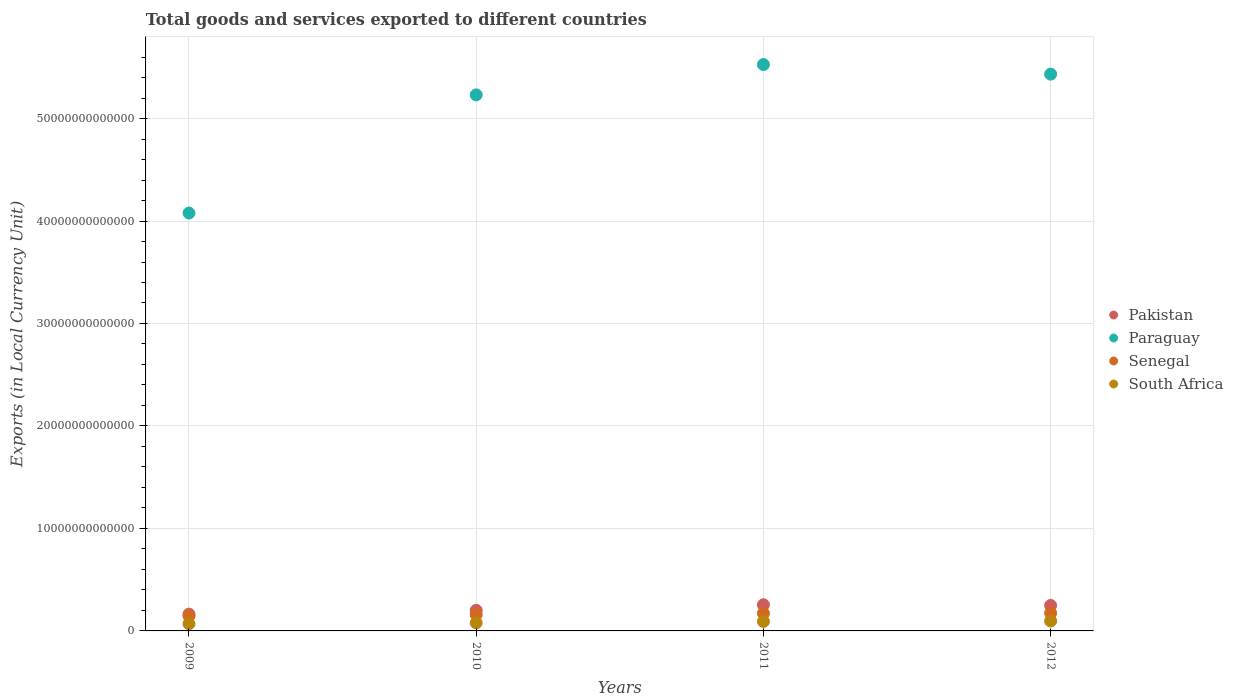Is the number of dotlines equal to the number of legend labels?
Make the answer very short. Yes. What is the Amount of goods and services exports in South Africa in 2011?
Make the answer very short. 9.21e+11. Across all years, what is the maximum Amount of goods and services exports in Senegal?
Ensure brevity in your answer.  1.74e+12. Across all years, what is the minimum Amount of goods and services exports in Senegal?
Make the answer very short. 1.47e+12. In which year was the Amount of goods and services exports in Senegal maximum?
Your answer should be very brief. 2012. What is the total Amount of goods and services exports in Senegal in the graph?
Provide a succinct answer. 6.52e+12. What is the difference between the Amount of goods and services exports in Paraguay in 2009 and that in 2012?
Your response must be concise. -1.36e+13. What is the difference between the Amount of goods and services exports in Pakistan in 2011 and the Amount of goods and services exports in Paraguay in 2010?
Make the answer very short. -4.98e+13. What is the average Amount of goods and services exports in Senegal per year?
Your answer should be compact. 1.63e+12. In the year 2011, what is the difference between the Amount of goods and services exports in Senegal and Amount of goods and services exports in Pakistan?
Keep it short and to the point. -8.38e+11. In how many years, is the Amount of goods and services exports in South Africa greater than 16000000000000 LCU?
Ensure brevity in your answer.  0. What is the ratio of the Amount of goods and services exports in Senegal in 2011 to that in 2012?
Provide a short and direct response. 0.98. What is the difference between the highest and the second highest Amount of goods and services exports in Senegal?
Ensure brevity in your answer.  2.69e+1. What is the difference between the highest and the lowest Amount of goods and services exports in South Africa?
Offer a terse response. 2.70e+11. Is the sum of the Amount of goods and services exports in Paraguay in 2011 and 2012 greater than the maximum Amount of goods and services exports in Senegal across all years?
Your response must be concise. Yes. Does the Amount of goods and services exports in Paraguay monotonically increase over the years?
Your response must be concise. No. Is the Amount of goods and services exports in Paraguay strictly less than the Amount of goods and services exports in Senegal over the years?
Offer a terse response. No. How many dotlines are there?
Your answer should be very brief. 4. What is the difference between two consecutive major ticks on the Y-axis?
Ensure brevity in your answer.  1.00e+13. Does the graph contain any zero values?
Provide a short and direct response. No. Where does the legend appear in the graph?
Your answer should be compact. Center right. How many legend labels are there?
Make the answer very short. 4. What is the title of the graph?
Your response must be concise. Total goods and services exported to different countries. What is the label or title of the X-axis?
Make the answer very short. Years. What is the label or title of the Y-axis?
Give a very brief answer. Exports (in Local Currency Unit). What is the Exports (in Local Currency Unit) in Pakistan in 2009?
Provide a short and direct response. 1.64e+12. What is the Exports (in Local Currency Unit) in Paraguay in 2009?
Provide a succinct answer. 4.08e+13. What is the Exports (in Local Currency Unit) of Senegal in 2009?
Offer a very short reply. 1.47e+12. What is the Exports (in Local Currency Unit) of South Africa in 2009?
Offer a terse response. 7.00e+11. What is the Exports (in Local Currency Unit) of Pakistan in 2010?
Provide a short and direct response. 2.01e+12. What is the Exports (in Local Currency Unit) of Paraguay in 2010?
Your answer should be compact. 5.23e+13. What is the Exports (in Local Currency Unit) in Senegal in 2010?
Keep it short and to the point. 1.59e+12. What is the Exports (in Local Currency Unit) in South Africa in 2010?
Keep it short and to the point. 7.86e+11. What is the Exports (in Local Currency Unit) of Pakistan in 2011?
Your response must be concise. 2.55e+12. What is the Exports (in Local Currency Unit) of Paraguay in 2011?
Your answer should be very brief. 5.53e+13. What is the Exports (in Local Currency Unit) of Senegal in 2011?
Keep it short and to the point. 1.71e+12. What is the Exports (in Local Currency Unit) of South Africa in 2011?
Provide a short and direct response. 9.21e+11. What is the Exports (in Local Currency Unit) of Pakistan in 2012?
Give a very brief answer. 2.49e+12. What is the Exports (in Local Currency Unit) of Paraguay in 2012?
Give a very brief answer. 5.43e+13. What is the Exports (in Local Currency Unit) in Senegal in 2012?
Your response must be concise. 1.74e+12. What is the Exports (in Local Currency Unit) of South Africa in 2012?
Offer a terse response. 9.70e+11. Across all years, what is the maximum Exports (in Local Currency Unit) in Pakistan?
Provide a short and direct response. 2.55e+12. Across all years, what is the maximum Exports (in Local Currency Unit) of Paraguay?
Keep it short and to the point. 5.53e+13. Across all years, what is the maximum Exports (in Local Currency Unit) in Senegal?
Your answer should be very brief. 1.74e+12. Across all years, what is the maximum Exports (in Local Currency Unit) of South Africa?
Keep it short and to the point. 9.70e+11. Across all years, what is the minimum Exports (in Local Currency Unit) of Pakistan?
Your answer should be very brief. 1.64e+12. Across all years, what is the minimum Exports (in Local Currency Unit) in Paraguay?
Give a very brief answer. 4.08e+13. Across all years, what is the minimum Exports (in Local Currency Unit) in Senegal?
Offer a very short reply. 1.47e+12. Across all years, what is the minimum Exports (in Local Currency Unit) of South Africa?
Your answer should be very brief. 7.00e+11. What is the total Exports (in Local Currency Unit) of Pakistan in the graph?
Give a very brief answer. 8.68e+12. What is the total Exports (in Local Currency Unit) of Paraguay in the graph?
Provide a short and direct response. 2.03e+14. What is the total Exports (in Local Currency Unit) in Senegal in the graph?
Offer a very short reply. 6.52e+12. What is the total Exports (in Local Currency Unit) of South Africa in the graph?
Offer a very short reply. 3.38e+12. What is the difference between the Exports (in Local Currency Unit) in Pakistan in 2009 and that in 2010?
Your answer should be very brief. -3.73e+11. What is the difference between the Exports (in Local Currency Unit) in Paraguay in 2009 and that in 2010?
Provide a succinct answer. -1.15e+13. What is the difference between the Exports (in Local Currency Unit) in Senegal in 2009 and that in 2010?
Offer a terse response. -1.21e+11. What is the difference between the Exports (in Local Currency Unit) of South Africa in 2009 and that in 2010?
Offer a very short reply. -8.64e+1. What is the difference between the Exports (in Local Currency Unit) in Pakistan in 2009 and that in 2011?
Your answer should be very brief. -9.16e+11. What is the difference between the Exports (in Local Currency Unit) of Paraguay in 2009 and that in 2011?
Give a very brief answer. -1.45e+13. What is the difference between the Exports (in Local Currency Unit) in Senegal in 2009 and that in 2011?
Provide a succinct answer. -2.43e+11. What is the difference between the Exports (in Local Currency Unit) in South Africa in 2009 and that in 2011?
Provide a short and direct response. -2.21e+11. What is the difference between the Exports (in Local Currency Unit) of Pakistan in 2009 and that in 2012?
Your answer should be very brief. -8.49e+11. What is the difference between the Exports (in Local Currency Unit) of Paraguay in 2009 and that in 2012?
Make the answer very short. -1.36e+13. What is the difference between the Exports (in Local Currency Unit) in Senegal in 2009 and that in 2012?
Provide a succinct answer. -2.70e+11. What is the difference between the Exports (in Local Currency Unit) in South Africa in 2009 and that in 2012?
Provide a succinct answer. -2.70e+11. What is the difference between the Exports (in Local Currency Unit) in Pakistan in 2010 and that in 2011?
Offer a very short reply. -5.43e+11. What is the difference between the Exports (in Local Currency Unit) in Paraguay in 2010 and that in 2011?
Your answer should be very brief. -2.96e+12. What is the difference between the Exports (in Local Currency Unit) in Senegal in 2010 and that in 2011?
Give a very brief answer. -1.22e+11. What is the difference between the Exports (in Local Currency Unit) in South Africa in 2010 and that in 2011?
Give a very brief answer. -1.35e+11. What is the difference between the Exports (in Local Currency Unit) in Pakistan in 2010 and that in 2012?
Keep it short and to the point. -4.76e+11. What is the difference between the Exports (in Local Currency Unit) in Paraguay in 2010 and that in 2012?
Keep it short and to the point. -2.02e+12. What is the difference between the Exports (in Local Currency Unit) in Senegal in 2010 and that in 2012?
Offer a terse response. -1.49e+11. What is the difference between the Exports (in Local Currency Unit) in South Africa in 2010 and that in 2012?
Keep it short and to the point. -1.83e+11. What is the difference between the Exports (in Local Currency Unit) in Pakistan in 2011 and that in 2012?
Offer a terse response. 6.75e+1. What is the difference between the Exports (in Local Currency Unit) in Paraguay in 2011 and that in 2012?
Make the answer very short. 9.38e+11. What is the difference between the Exports (in Local Currency Unit) in Senegal in 2011 and that in 2012?
Offer a very short reply. -2.69e+1. What is the difference between the Exports (in Local Currency Unit) in South Africa in 2011 and that in 2012?
Offer a terse response. -4.89e+1. What is the difference between the Exports (in Local Currency Unit) of Pakistan in 2009 and the Exports (in Local Currency Unit) of Paraguay in 2010?
Offer a very short reply. -5.07e+13. What is the difference between the Exports (in Local Currency Unit) in Pakistan in 2009 and the Exports (in Local Currency Unit) in Senegal in 2010?
Offer a very short reply. 4.36e+1. What is the difference between the Exports (in Local Currency Unit) of Pakistan in 2009 and the Exports (in Local Currency Unit) of South Africa in 2010?
Your response must be concise. 8.50e+11. What is the difference between the Exports (in Local Currency Unit) of Paraguay in 2009 and the Exports (in Local Currency Unit) of Senegal in 2010?
Ensure brevity in your answer.  3.92e+13. What is the difference between the Exports (in Local Currency Unit) in Paraguay in 2009 and the Exports (in Local Currency Unit) in South Africa in 2010?
Offer a terse response. 4.00e+13. What is the difference between the Exports (in Local Currency Unit) in Senegal in 2009 and the Exports (in Local Currency Unit) in South Africa in 2010?
Provide a short and direct response. 6.85e+11. What is the difference between the Exports (in Local Currency Unit) of Pakistan in 2009 and the Exports (in Local Currency Unit) of Paraguay in 2011?
Keep it short and to the point. -5.36e+13. What is the difference between the Exports (in Local Currency Unit) of Pakistan in 2009 and the Exports (in Local Currency Unit) of Senegal in 2011?
Your response must be concise. -7.87e+1. What is the difference between the Exports (in Local Currency Unit) in Pakistan in 2009 and the Exports (in Local Currency Unit) in South Africa in 2011?
Provide a succinct answer. 7.15e+11. What is the difference between the Exports (in Local Currency Unit) in Paraguay in 2009 and the Exports (in Local Currency Unit) in Senegal in 2011?
Your answer should be compact. 3.91e+13. What is the difference between the Exports (in Local Currency Unit) in Paraguay in 2009 and the Exports (in Local Currency Unit) in South Africa in 2011?
Keep it short and to the point. 3.99e+13. What is the difference between the Exports (in Local Currency Unit) in Senegal in 2009 and the Exports (in Local Currency Unit) in South Africa in 2011?
Make the answer very short. 5.51e+11. What is the difference between the Exports (in Local Currency Unit) in Pakistan in 2009 and the Exports (in Local Currency Unit) in Paraguay in 2012?
Your answer should be compact. -5.27e+13. What is the difference between the Exports (in Local Currency Unit) of Pakistan in 2009 and the Exports (in Local Currency Unit) of Senegal in 2012?
Provide a succinct answer. -1.06e+11. What is the difference between the Exports (in Local Currency Unit) in Pakistan in 2009 and the Exports (in Local Currency Unit) in South Africa in 2012?
Your response must be concise. 6.66e+11. What is the difference between the Exports (in Local Currency Unit) of Paraguay in 2009 and the Exports (in Local Currency Unit) of Senegal in 2012?
Provide a succinct answer. 3.90e+13. What is the difference between the Exports (in Local Currency Unit) of Paraguay in 2009 and the Exports (in Local Currency Unit) of South Africa in 2012?
Your answer should be very brief. 3.98e+13. What is the difference between the Exports (in Local Currency Unit) of Senegal in 2009 and the Exports (in Local Currency Unit) of South Africa in 2012?
Offer a terse response. 5.02e+11. What is the difference between the Exports (in Local Currency Unit) of Pakistan in 2010 and the Exports (in Local Currency Unit) of Paraguay in 2011?
Your answer should be very brief. -5.33e+13. What is the difference between the Exports (in Local Currency Unit) in Pakistan in 2010 and the Exports (in Local Currency Unit) in Senegal in 2011?
Keep it short and to the point. 2.95e+11. What is the difference between the Exports (in Local Currency Unit) of Pakistan in 2010 and the Exports (in Local Currency Unit) of South Africa in 2011?
Keep it short and to the point. 1.09e+12. What is the difference between the Exports (in Local Currency Unit) of Paraguay in 2010 and the Exports (in Local Currency Unit) of Senegal in 2011?
Provide a short and direct response. 5.06e+13. What is the difference between the Exports (in Local Currency Unit) in Paraguay in 2010 and the Exports (in Local Currency Unit) in South Africa in 2011?
Offer a terse response. 5.14e+13. What is the difference between the Exports (in Local Currency Unit) in Senegal in 2010 and the Exports (in Local Currency Unit) in South Africa in 2011?
Your answer should be very brief. 6.72e+11. What is the difference between the Exports (in Local Currency Unit) of Pakistan in 2010 and the Exports (in Local Currency Unit) of Paraguay in 2012?
Ensure brevity in your answer.  -5.23e+13. What is the difference between the Exports (in Local Currency Unit) in Pakistan in 2010 and the Exports (in Local Currency Unit) in Senegal in 2012?
Your answer should be very brief. 2.68e+11. What is the difference between the Exports (in Local Currency Unit) in Pakistan in 2010 and the Exports (in Local Currency Unit) in South Africa in 2012?
Keep it short and to the point. 1.04e+12. What is the difference between the Exports (in Local Currency Unit) in Paraguay in 2010 and the Exports (in Local Currency Unit) in Senegal in 2012?
Your answer should be very brief. 5.06e+13. What is the difference between the Exports (in Local Currency Unit) of Paraguay in 2010 and the Exports (in Local Currency Unit) of South Africa in 2012?
Provide a short and direct response. 5.13e+13. What is the difference between the Exports (in Local Currency Unit) in Senegal in 2010 and the Exports (in Local Currency Unit) in South Africa in 2012?
Your response must be concise. 6.23e+11. What is the difference between the Exports (in Local Currency Unit) of Pakistan in 2011 and the Exports (in Local Currency Unit) of Paraguay in 2012?
Provide a short and direct response. -5.18e+13. What is the difference between the Exports (in Local Currency Unit) in Pakistan in 2011 and the Exports (in Local Currency Unit) in Senegal in 2012?
Offer a terse response. 8.11e+11. What is the difference between the Exports (in Local Currency Unit) of Pakistan in 2011 and the Exports (in Local Currency Unit) of South Africa in 2012?
Keep it short and to the point. 1.58e+12. What is the difference between the Exports (in Local Currency Unit) in Paraguay in 2011 and the Exports (in Local Currency Unit) in Senegal in 2012?
Provide a short and direct response. 5.35e+13. What is the difference between the Exports (in Local Currency Unit) of Paraguay in 2011 and the Exports (in Local Currency Unit) of South Africa in 2012?
Ensure brevity in your answer.  5.43e+13. What is the difference between the Exports (in Local Currency Unit) in Senegal in 2011 and the Exports (in Local Currency Unit) in South Africa in 2012?
Provide a succinct answer. 7.45e+11. What is the average Exports (in Local Currency Unit) in Pakistan per year?
Your answer should be very brief. 2.17e+12. What is the average Exports (in Local Currency Unit) in Paraguay per year?
Your response must be concise. 5.07e+13. What is the average Exports (in Local Currency Unit) of Senegal per year?
Provide a succinct answer. 1.63e+12. What is the average Exports (in Local Currency Unit) in South Africa per year?
Offer a terse response. 8.44e+11. In the year 2009, what is the difference between the Exports (in Local Currency Unit) in Pakistan and Exports (in Local Currency Unit) in Paraguay?
Give a very brief answer. -3.91e+13. In the year 2009, what is the difference between the Exports (in Local Currency Unit) in Pakistan and Exports (in Local Currency Unit) in Senegal?
Your answer should be compact. 1.64e+11. In the year 2009, what is the difference between the Exports (in Local Currency Unit) in Pakistan and Exports (in Local Currency Unit) in South Africa?
Offer a very short reply. 9.36e+11. In the year 2009, what is the difference between the Exports (in Local Currency Unit) of Paraguay and Exports (in Local Currency Unit) of Senegal?
Your response must be concise. 3.93e+13. In the year 2009, what is the difference between the Exports (in Local Currency Unit) of Paraguay and Exports (in Local Currency Unit) of South Africa?
Provide a succinct answer. 4.01e+13. In the year 2009, what is the difference between the Exports (in Local Currency Unit) of Senegal and Exports (in Local Currency Unit) of South Africa?
Ensure brevity in your answer.  7.72e+11. In the year 2010, what is the difference between the Exports (in Local Currency Unit) in Pakistan and Exports (in Local Currency Unit) in Paraguay?
Your answer should be compact. -5.03e+13. In the year 2010, what is the difference between the Exports (in Local Currency Unit) of Pakistan and Exports (in Local Currency Unit) of Senegal?
Offer a very short reply. 4.17e+11. In the year 2010, what is the difference between the Exports (in Local Currency Unit) in Pakistan and Exports (in Local Currency Unit) in South Africa?
Offer a terse response. 1.22e+12. In the year 2010, what is the difference between the Exports (in Local Currency Unit) in Paraguay and Exports (in Local Currency Unit) in Senegal?
Ensure brevity in your answer.  5.07e+13. In the year 2010, what is the difference between the Exports (in Local Currency Unit) in Paraguay and Exports (in Local Currency Unit) in South Africa?
Provide a succinct answer. 5.15e+13. In the year 2010, what is the difference between the Exports (in Local Currency Unit) in Senegal and Exports (in Local Currency Unit) in South Africa?
Offer a terse response. 8.06e+11. In the year 2011, what is the difference between the Exports (in Local Currency Unit) of Pakistan and Exports (in Local Currency Unit) of Paraguay?
Provide a short and direct response. -5.27e+13. In the year 2011, what is the difference between the Exports (in Local Currency Unit) of Pakistan and Exports (in Local Currency Unit) of Senegal?
Your response must be concise. 8.38e+11. In the year 2011, what is the difference between the Exports (in Local Currency Unit) of Pakistan and Exports (in Local Currency Unit) of South Africa?
Give a very brief answer. 1.63e+12. In the year 2011, what is the difference between the Exports (in Local Currency Unit) in Paraguay and Exports (in Local Currency Unit) in Senegal?
Keep it short and to the point. 5.36e+13. In the year 2011, what is the difference between the Exports (in Local Currency Unit) in Paraguay and Exports (in Local Currency Unit) in South Africa?
Offer a very short reply. 5.43e+13. In the year 2011, what is the difference between the Exports (in Local Currency Unit) of Senegal and Exports (in Local Currency Unit) of South Africa?
Your answer should be very brief. 7.94e+11. In the year 2012, what is the difference between the Exports (in Local Currency Unit) of Pakistan and Exports (in Local Currency Unit) of Paraguay?
Ensure brevity in your answer.  -5.18e+13. In the year 2012, what is the difference between the Exports (in Local Currency Unit) of Pakistan and Exports (in Local Currency Unit) of Senegal?
Offer a very short reply. 7.43e+11. In the year 2012, what is the difference between the Exports (in Local Currency Unit) in Pakistan and Exports (in Local Currency Unit) in South Africa?
Your answer should be very brief. 1.52e+12. In the year 2012, what is the difference between the Exports (in Local Currency Unit) of Paraguay and Exports (in Local Currency Unit) of Senegal?
Your answer should be very brief. 5.26e+13. In the year 2012, what is the difference between the Exports (in Local Currency Unit) in Paraguay and Exports (in Local Currency Unit) in South Africa?
Ensure brevity in your answer.  5.34e+13. In the year 2012, what is the difference between the Exports (in Local Currency Unit) of Senegal and Exports (in Local Currency Unit) of South Africa?
Offer a very short reply. 7.72e+11. What is the ratio of the Exports (in Local Currency Unit) of Pakistan in 2009 to that in 2010?
Make the answer very short. 0.81. What is the ratio of the Exports (in Local Currency Unit) in Paraguay in 2009 to that in 2010?
Your answer should be compact. 0.78. What is the ratio of the Exports (in Local Currency Unit) of Senegal in 2009 to that in 2010?
Give a very brief answer. 0.92. What is the ratio of the Exports (in Local Currency Unit) in South Africa in 2009 to that in 2010?
Offer a very short reply. 0.89. What is the ratio of the Exports (in Local Currency Unit) of Pakistan in 2009 to that in 2011?
Your answer should be compact. 0.64. What is the ratio of the Exports (in Local Currency Unit) in Paraguay in 2009 to that in 2011?
Offer a very short reply. 0.74. What is the ratio of the Exports (in Local Currency Unit) in Senegal in 2009 to that in 2011?
Give a very brief answer. 0.86. What is the ratio of the Exports (in Local Currency Unit) of South Africa in 2009 to that in 2011?
Make the answer very short. 0.76. What is the ratio of the Exports (in Local Currency Unit) of Pakistan in 2009 to that in 2012?
Offer a very short reply. 0.66. What is the ratio of the Exports (in Local Currency Unit) in Paraguay in 2009 to that in 2012?
Ensure brevity in your answer.  0.75. What is the ratio of the Exports (in Local Currency Unit) in Senegal in 2009 to that in 2012?
Offer a terse response. 0.84. What is the ratio of the Exports (in Local Currency Unit) of South Africa in 2009 to that in 2012?
Ensure brevity in your answer.  0.72. What is the ratio of the Exports (in Local Currency Unit) in Pakistan in 2010 to that in 2011?
Provide a succinct answer. 0.79. What is the ratio of the Exports (in Local Currency Unit) of Paraguay in 2010 to that in 2011?
Give a very brief answer. 0.95. What is the ratio of the Exports (in Local Currency Unit) of Senegal in 2010 to that in 2011?
Ensure brevity in your answer.  0.93. What is the ratio of the Exports (in Local Currency Unit) of South Africa in 2010 to that in 2011?
Provide a short and direct response. 0.85. What is the ratio of the Exports (in Local Currency Unit) of Pakistan in 2010 to that in 2012?
Your response must be concise. 0.81. What is the ratio of the Exports (in Local Currency Unit) in Paraguay in 2010 to that in 2012?
Provide a succinct answer. 0.96. What is the ratio of the Exports (in Local Currency Unit) of Senegal in 2010 to that in 2012?
Provide a short and direct response. 0.91. What is the ratio of the Exports (in Local Currency Unit) in South Africa in 2010 to that in 2012?
Your answer should be compact. 0.81. What is the ratio of the Exports (in Local Currency Unit) in Pakistan in 2011 to that in 2012?
Make the answer very short. 1.03. What is the ratio of the Exports (in Local Currency Unit) in Paraguay in 2011 to that in 2012?
Your answer should be compact. 1.02. What is the ratio of the Exports (in Local Currency Unit) of Senegal in 2011 to that in 2012?
Offer a terse response. 0.98. What is the ratio of the Exports (in Local Currency Unit) of South Africa in 2011 to that in 2012?
Your answer should be compact. 0.95. What is the difference between the highest and the second highest Exports (in Local Currency Unit) in Pakistan?
Your response must be concise. 6.75e+1. What is the difference between the highest and the second highest Exports (in Local Currency Unit) in Paraguay?
Provide a succinct answer. 9.38e+11. What is the difference between the highest and the second highest Exports (in Local Currency Unit) in Senegal?
Your answer should be compact. 2.69e+1. What is the difference between the highest and the second highest Exports (in Local Currency Unit) of South Africa?
Make the answer very short. 4.89e+1. What is the difference between the highest and the lowest Exports (in Local Currency Unit) in Pakistan?
Your response must be concise. 9.16e+11. What is the difference between the highest and the lowest Exports (in Local Currency Unit) in Paraguay?
Provide a succinct answer. 1.45e+13. What is the difference between the highest and the lowest Exports (in Local Currency Unit) of Senegal?
Ensure brevity in your answer.  2.70e+11. What is the difference between the highest and the lowest Exports (in Local Currency Unit) in South Africa?
Keep it short and to the point. 2.70e+11. 